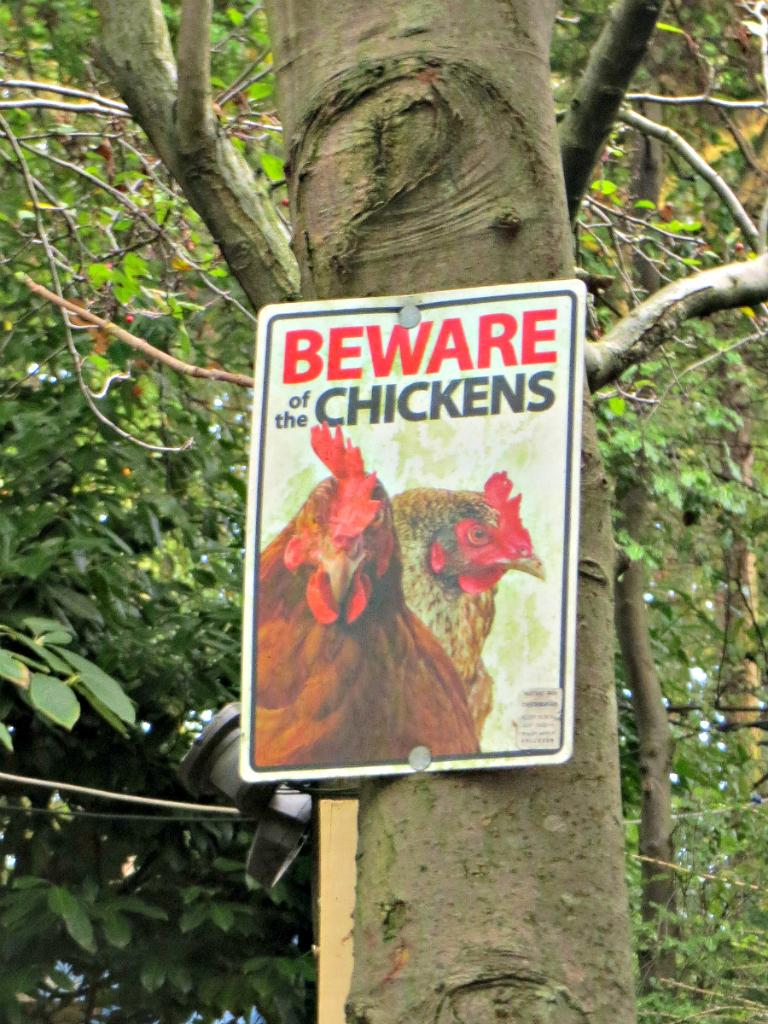What is located in the center of the image? There are trees in the center of the image. What else can be seen in the image? There is a banner in the image. What message is written on the banner? The banner has the text "Beware Of The Chickens" written on it. What type of comfort can be found in the image? There is no information about comfort in the image; it primarily features trees and a banner with a message. 